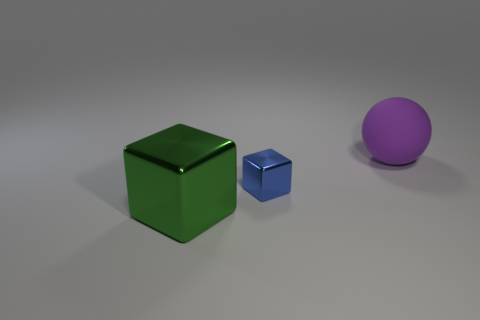Can you describe the colors and shapes visible in this image? Certainly! In the image, there are three distinct objects, each with a unique color and shape. On the left, there's a large green cube with a shiny surface, suggesting it might be made of a material like plastic. To its right, there's a smaller blue cube, also with a glossy finish that may indicate it's metallic. And to the far right, there is a large purple sphere with a matte surface, providing a contrast in both color and texture to the other objects. 